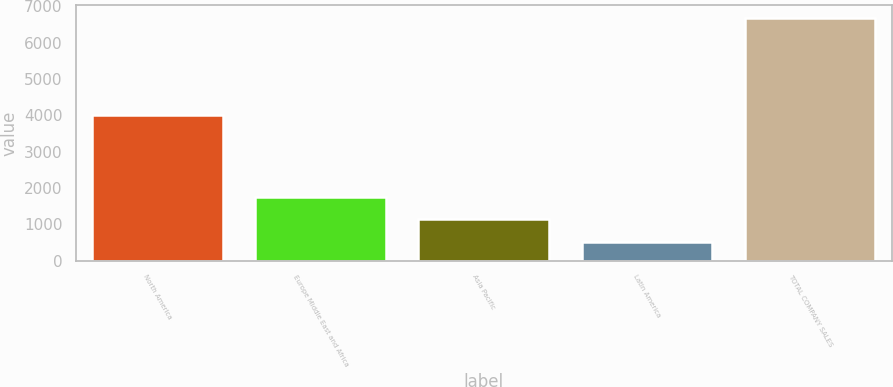Convert chart. <chart><loc_0><loc_0><loc_500><loc_500><bar_chart><fcel>North America<fcel>Europe Middle East and Africa<fcel>Asia Pacific<fcel>Latin America<fcel>TOTAL COMPANY SALES<nl><fcel>4014.3<fcel>1756.64<fcel>1139.37<fcel>522.1<fcel>6694.8<nl></chart> 